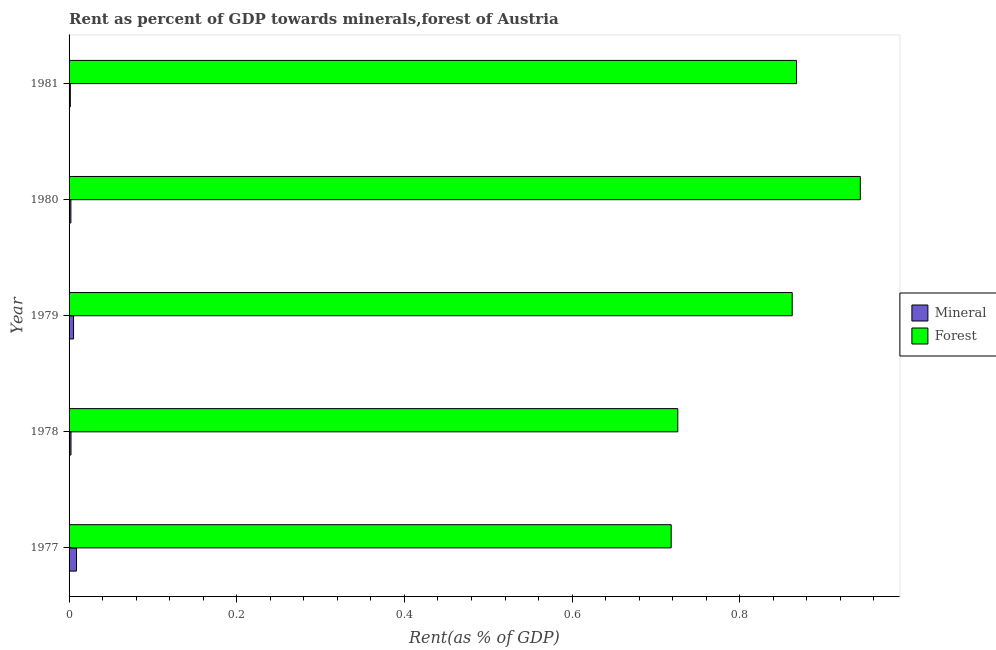How many different coloured bars are there?
Give a very brief answer. 2. Are the number of bars on each tick of the Y-axis equal?
Your answer should be compact. Yes. How many bars are there on the 5th tick from the bottom?
Give a very brief answer. 2. What is the label of the 2nd group of bars from the top?
Give a very brief answer. 1980. What is the mineral rent in 1977?
Keep it short and to the point. 0.01. Across all years, what is the maximum mineral rent?
Keep it short and to the point. 0.01. Across all years, what is the minimum mineral rent?
Ensure brevity in your answer.  0. What is the total forest rent in the graph?
Your answer should be compact. 4.12. What is the difference between the forest rent in 1979 and that in 1980?
Provide a succinct answer. -0.08. What is the difference between the forest rent in 1981 and the mineral rent in 1980?
Make the answer very short. 0.87. What is the average mineral rent per year?
Ensure brevity in your answer.  0. In the year 1980, what is the difference between the mineral rent and forest rent?
Keep it short and to the point. -0.94. In how many years, is the forest rent greater than 0.56 %?
Your answer should be very brief. 5. Is the forest rent in 1980 less than that in 1981?
Your answer should be very brief. No. What is the difference between the highest and the second highest forest rent?
Offer a very short reply. 0.08. What is the difference between the highest and the lowest mineral rent?
Make the answer very short. 0.01. In how many years, is the forest rent greater than the average forest rent taken over all years?
Your answer should be compact. 3. Is the sum of the forest rent in 1977 and 1979 greater than the maximum mineral rent across all years?
Your answer should be very brief. Yes. What does the 1st bar from the top in 1978 represents?
Offer a terse response. Forest. What does the 2nd bar from the bottom in 1978 represents?
Your answer should be very brief. Forest. How many bars are there?
Provide a succinct answer. 10. What is the difference between two consecutive major ticks on the X-axis?
Your response must be concise. 0.2. Does the graph contain any zero values?
Provide a short and direct response. No. Does the graph contain grids?
Make the answer very short. No. Where does the legend appear in the graph?
Provide a short and direct response. Center right. How many legend labels are there?
Ensure brevity in your answer.  2. How are the legend labels stacked?
Keep it short and to the point. Vertical. What is the title of the graph?
Offer a very short reply. Rent as percent of GDP towards minerals,forest of Austria. Does "Technicians" appear as one of the legend labels in the graph?
Ensure brevity in your answer.  No. What is the label or title of the X-axis?
Your answer should be compact. Rent(as % of GDP). What is the label or title of the Y-axis?
Give a very brief answer. Year. What is the Rent(as % of GDP) in Mineral in 1977?
Offer a terse response. 0.01. What is the Rent(as % of GDP) in Forest in 1977?
Make the answer very short. 0.72. What is the Rent(as % of GDP) in Mineral in 1978?
Provide a short and direct response. 0. What is the Rent(as % of GDP) in Forest in 1978?
Your response must be concise. 0.73. What is the Rent(as % of GDP) in Mineral in 1979?
Your response must be concise. 0.01. What is the Rent(as % of GDP) of Forest in 1979?
Your answer should be compact. 0.86. What is the Rent(as % of GDP) of Mineral in 1980?
Give a very brief answer. 0. What is the Rent(as % of GDP) in Forest in 1980?
Your answer should be very brief. 0.94. What is the Rent(as % of GDP) in Mineral in 1981?
Make the answer very short. 0. What is the Rent(as % of GDP) in Forest in 1981?
Ensure brevity in your answer.  0.87. Across all years, what is the maximum Rent(as % of GDP) of Mineral?
Make the answer very short. 0.01. Across all years, what is the maximum Rent(as % of GDP) of Forest?
Your answer should be very brief. 0.94. Across all years, what is the minimum Rent(as % of GDP) in Mineral?
Your answer should be very brief. 0. Across all years, what is the minimum Rent(as % of GDP) in Forest?
Your answer should be very brief. 0.72. What is the total Rent(as % of GDP) in Mineral in the graph?
Your answer should be very brief. 0.02. What is the total Rent(as % of GDP) in Forest in the graph?
Keep it short and to the point. 4.12. What is the difference between the Rent(as % of GDP) in Mineral in 1977 and that in 1978?
Offer a very short reply. 0.01. What is the difference between the Rent(as % of GDP) in Forest in 1977 and that in 1978?
Your answer should be compact. -0.01. What is the difference between the Rent(as % of GDP) in Mineral in 1977 and that in 1979?
Provide a short and direct response. 0. What is the difference between the Rent(as % of GDP) in Forest in 1977 and that in 1979?
Offer a very short reply. -0.14. What is the difference between the Rent(as % of GDP) in Mineral in 1977 and that in 1980?
Offer a terse response. 0.01. What is the difference between the Rent(as % of GDP) of Forest in 1977 and that in 1980?
Your response must be concise. -0.23. What is the difference between the Rent(as % of GDP) of Mineral in 1977 and that in 1981?
Offer a terse response. 0.01. What is the difference between the Rent(as % of GDP) of Forest in 1977 and that in 1981?
Your answer should be very brief. -0.15. What is the difference between the Rent(as % of GDP) in Mineral in 1978 and that in 1979?
Your response must be concise. -0. What is the difference between the Rent(as % of GDP) of Forest in 1978 and that in 1979?
Offer a terse response. -0.14. What is the difference between the Rent(as % of GDP) of Forest in 1978 and that in 1980?
Your answer should be compact. -0.22. What is the difference between the Rent(as % of GDP) of Mineral in 1978 and that in 1981?
Provide a succinct answer. 0. What is the difference between the Rent(as % of GDP) of Forest in 1978 and that in 1981?
Make the answer very short. -0.14. What is the difference between the Rent(as % of GDP) of Mineral in 1979 and that in 1980?
Ensure brevity in your answer.  0. What is the difference between the Rent(as % of GDP) of Forest in 1979 and that in 1980?
Ensure brevity in your answer.  -0.08. What is the difference between the Rent(as % of GDP) of Mineral in 1979 and that in 1981?
Keep it short and to the point. 0. What is the difference between the Rent(as % of GDP) of Forest in 1979 and that in 1981?
Ensure brevity in your answer.  -0.01. What is the difference between the Rent(as % of GDP) of Mineral in 1980 and that in 1981?
Your response must be concise. 0. What is the difference between the Rent(as % of GDP) of Forest in 1980 and that in 1981?
Give a very brief answer. 0.08. What is the difference between the Rent(as % of GDP) in Mineral in 1977 and the Rent(as % of GDP) in Forest in 1978?
Offer a very short reply. -0.72. What is the difference between the Rent(as % of GDP) of Mineral in 1977 and the Rent(as % of GDP) of Forest in 1979?
Provide a short and direct response. -0.85. What is the difference between the Rent(as % of GDP) in Mineral in 1977 and the Rent(as % of GDP) in Forest in 1980?
Give a very brief answer. -0.93. What is the difference between the Rent(as % of GDP) of Mineral in 1977 and the Rent(as % of GDP) of Forest in 1981?
Your answer should be compact. -0.86. What is the difference between the Rent(as % of GDP) in Mineral in 1978 and the Rent(as % of GDP) in Forest in 1979?
Offer a very short reply. -0.86. What is the difference between the Rent(as % of GDP) of Mineral in 1978 and the Rent(as % of GDP) of Forest in 1980?
Provide a succinct answer. -0.94. What is the difference between the Rent(as % of GDP) of Mineral in 1978 and the Rent(as % of GDP) of Forest in 1981?
Provide a succinct answer. -0.87. What is the difference between the Rent(as % of GDP) of Mineral in 1979 and the Rent(as % of GDP) of Forest in 1980?
Provide a short and direct response. -0.94. What is the difference between the Rent(as % of GDP) in Mineral in 1979 and the Rent(as % of GDP) in Forest in 1981?
Make the answer very short. -0.86. What is the difference between the Rent(as % of GDP) of Mineral in 1980 and the Rent(as % of GDP) of Forest in 1981?
Provide a succinct answer. -0.87. What is the average Rent(as % of GDP) of Mineral per year?
Offer a terse response. 0. What is the average Rent(as % of GDP) in Forest per year?
Your answer should be compact. 0.82. In the year 1977, what is the difference between the Rent(as % of GDP) of Mineral and Rent(as % of GDP) of Forest?
Provide a succinct answer. -0.71. In the year 1978, what is the difference between the Rent(as % of GDP) of Mineral and Rent(as % of GDP) of Forest?
Your answer should be compact. -0.72. In the year 1979, what is the difference between the Rent(as % of GDP) in Mineral and Rent(as % of GDP) in Forest?
Ensure brevity in your answer.  -0.86. In the year 1980, what is the difference between the Rent(as % of GDP) of Mineral and Rent(as % of GDP) of Forest?
Provide a succinct answer. -0.94. In the year 1981, what is the difference between the Rent(as % of GDP) of Mineral and Rent(as % of GDP) of Forest?
Ensure brevity in your answer.  -0.87. What is the ratio of the Rent(as % of GDP) in Mineral in 1977 to that in 1978?
Ensure brevity in your answer.  3.84. What is the ratio of the Rent(as % of GDP) of Forest in 1977 to that in 1978?
Your answer should be very brief. 0.99. What is the ratio of the Rent(as % of GDP) in Mineral in 1977 to that in 1979?
Ensure brevity in your answer.  1.66. What is the ratio of the Rent(as % of GDP) of Forest in 1977 to that in 1979?
Your answer should be very brief. 0.83. What is the ratio of the Rent(as % of GDP) of Mineral in 1977 to that in 1980?
Your answer should be very brief. 4.08. What is the ratio of the Rent(as % of GDP) in Forest in 1977 to that in 1980?
Provide a short and direct response. 0.76. What is the ratio of the Rent(as % of GDP) in Mineral in 1977 to that in 1981?
Offer a very short reply. 5.94. What is the ratio of the Rent(as % of GDP) in Forest in 1977 to that in 1981?
Your answer should be very brief. 0.83. What is the ratio of the Rent(as % of GDP) in Mineral in 1978 to that in 1979?
Provide a short and direct response. 0.43. What is the ratio of the Rent(as % of GDP) of Forest in 1978 to that in 1979?
Your response must be concise. 0.84. What is the ratio of the Rent(as % of GDP) of Mineral in 1978 to that in 1980?
Make the answer very short. 1.06. What is the ratio of the Rent(as % of GDP) of Forest in 1978 to that in 1980?
Ensure brevity in your answer.  0.77. What is the ratio of the Rent(as % of GDP) in Mineral in 1978 to that in 1981?
Provide a short and direct response. 1.55. What is the ratio of the Rent(as % of GDP) of Forest in 1978 to that in 1981?
Make the answer very short. 0.84. What is the ratio of the Rent(as % of GDP) in Mineral in 1979 to that in 1980?
Your answer should be compact. 2.47. What is the ratio of the Rent(as % of GDP) of Forest in 1979 to that in 1980?
Make the answer very short. 0.91. What is the ratio of the Rent(as % of GDP) of Mineral in 1979 to that in 1981?
Provide a short and direct response. 3.59. What is the ratio of the Rent(as % of GDP) of Forest in 1979 to that in 1981?
Ensure brevity in your answer.  0.99. What is the ratio of the Rent(as % of GDP) of Mineral in 1980 to that in 1981?
Offer a terse response. 1.46. What is the ratio of the Rent(as % of GDP) in Forest in 1980 to that in 1981?
Your response must be concise. 1.09. What is the difference between the highest and the second highest Rent(as % of GDP) of Mineral?
Provide a short and direct response. 0. What is the difference between the highest and the second highest Rent(as % of GDP) in Forest?
Offer a terse response. 0.08. What is the difference between the highest and the lowest Rent(as % of GDP) in Mineral?
Make the answer very short. 0.01. What is the difference between the highest and the lowest Rent(as % of GDP) in Forest?
Provide a short and direct response. 0.23. 